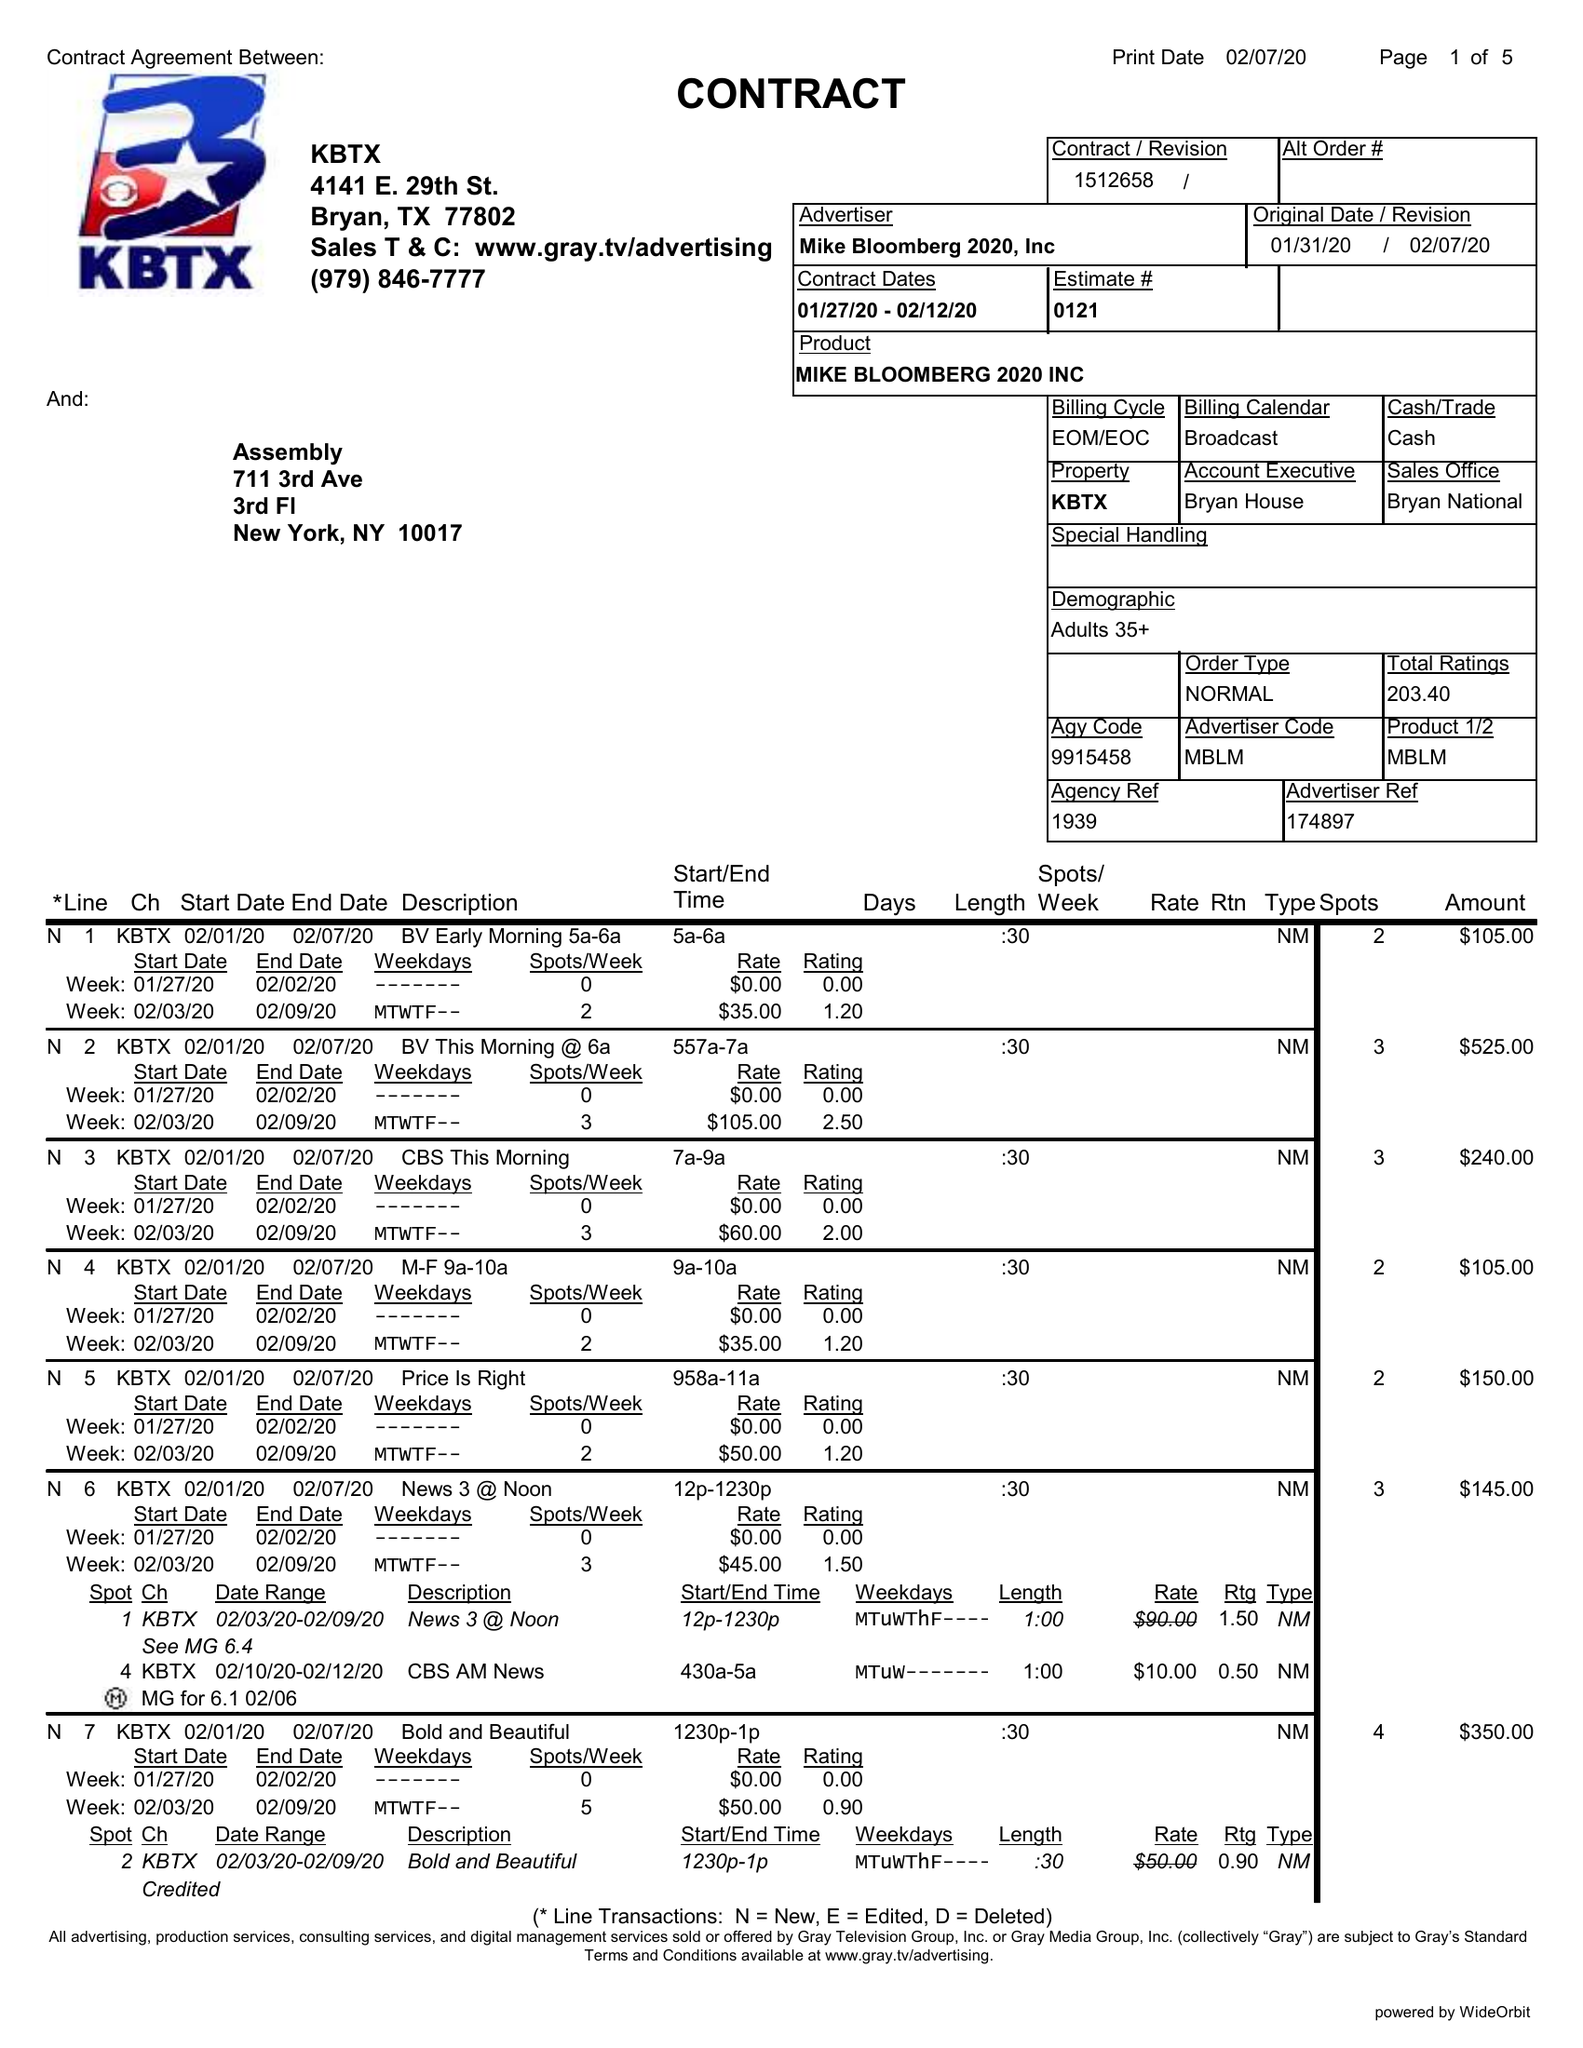What is the value for the flight_to?
Answer the question using a single word or phrase. 02/16/20 